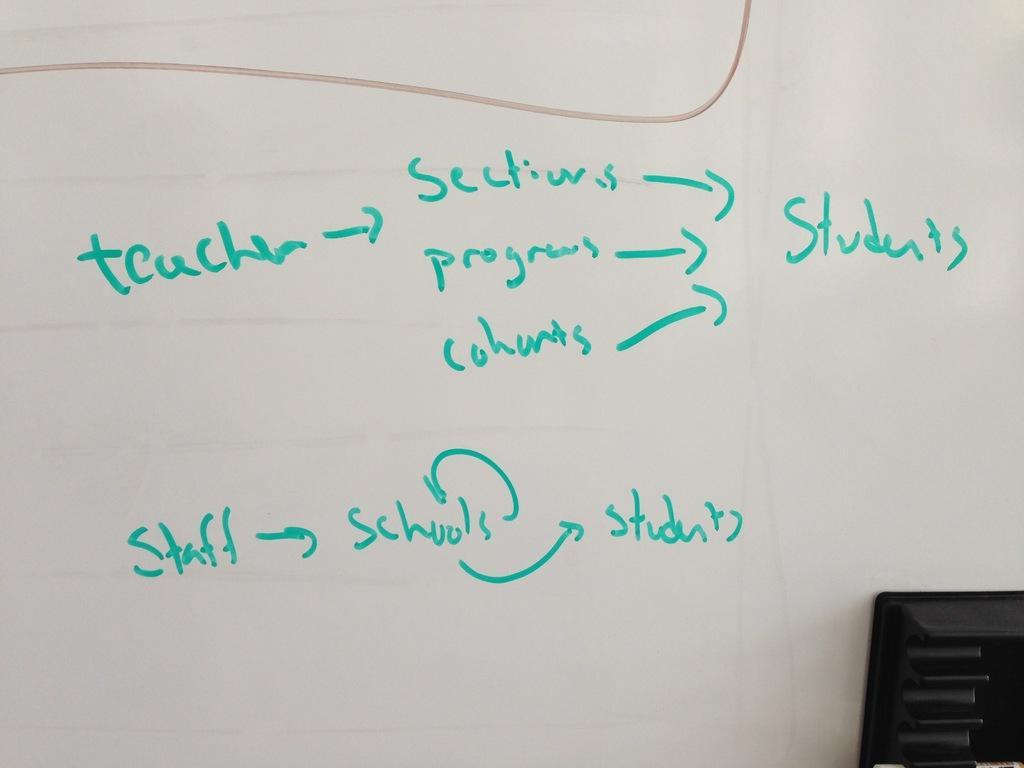How would you summarize this image in a sentence or two? In this picture I can see a white board and I can see some handwritten text on it. 